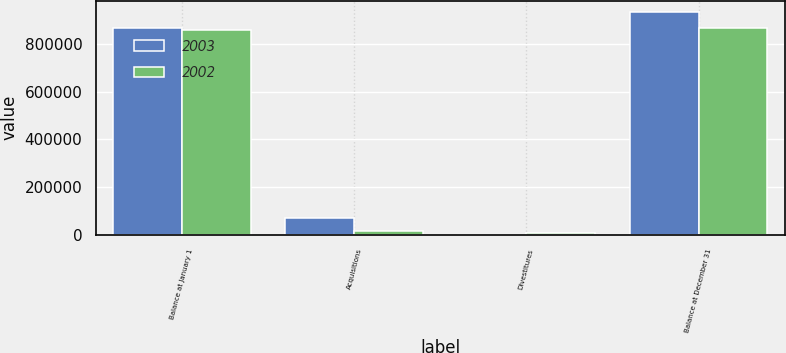Convert chart. <chart><loc_0><loc_0><loc_500><loc_500><stacked_bar_chart><ecel><fcel>Balance at January 1<fcel>Acquisitions<fcel>Divestitures<fcel>Balance at December 31<nl><fcel>2003<fcel>864786<fcel>70700<fcel>1298<fcel>934188<nl><fcel>2002<fcel>855760<fcel>15260<fcel>6234<fcel>864786<nl></chart> 